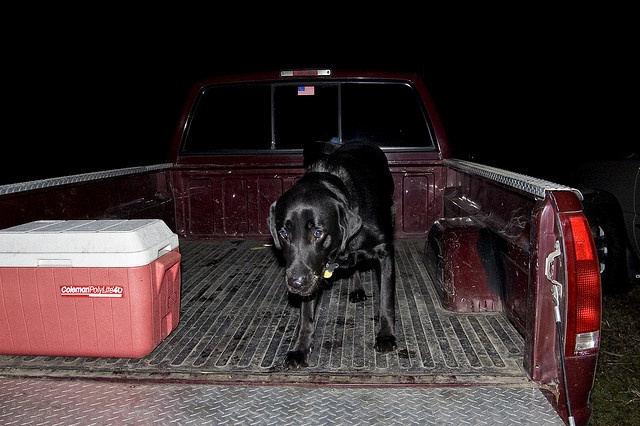Describe the objects in this image and their specific colors. I can see truck in black, gray, darkgray, and maroon tones and dog in black and gray tones in this image. 